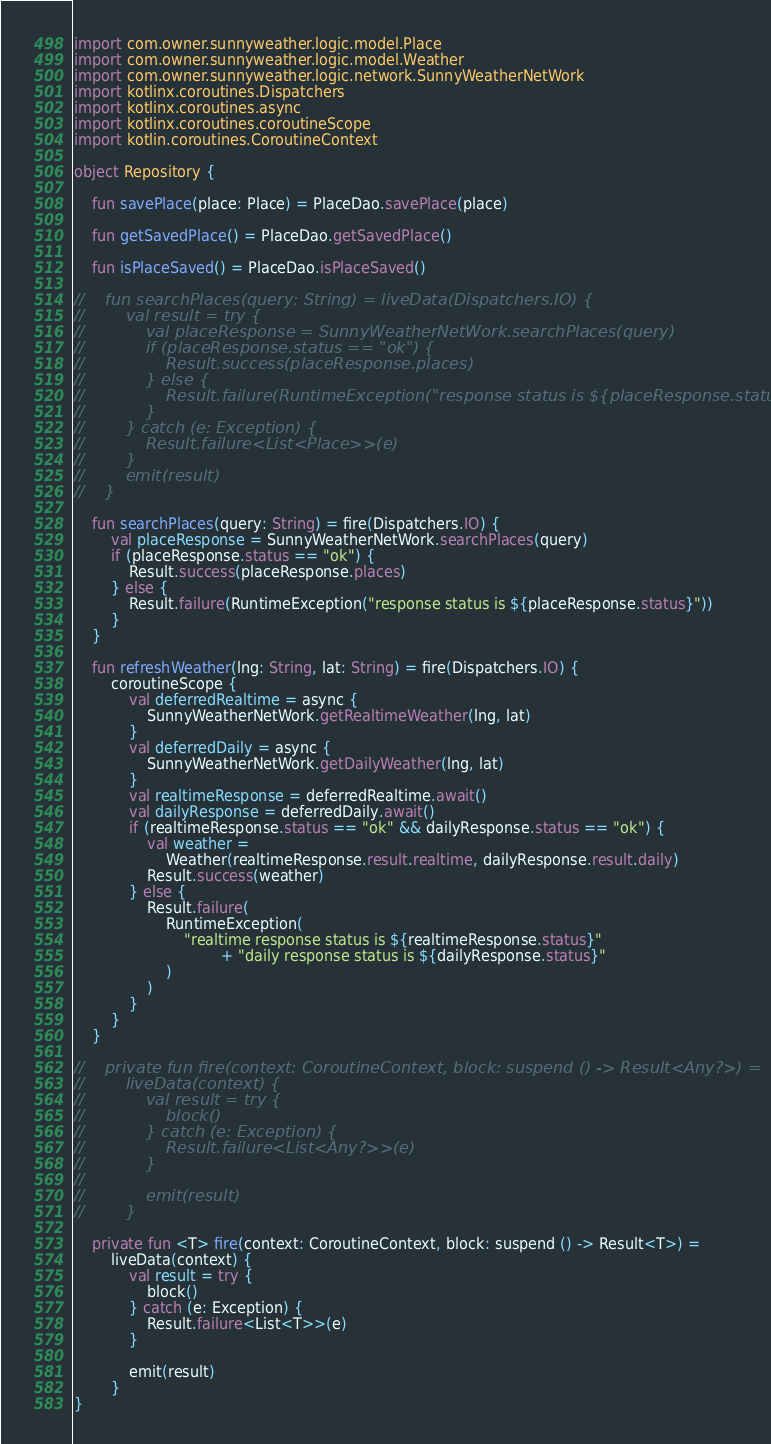<code> <loc_0><loc_0><loc_500><loc_500><_Kotlin_>import com.owner.sunnyweather.logic.model.Place
import com.owner.sunnyweather.logic.model.Weather
import com.owner.sunnyweather.logic.network.SunnyWeatherNetWork
import kotlinx.coroutines.Dispatchers
import kotlinx.coroutines.async
import kotlinx.coroutines.coroutineScope
import kotlin.coroutines.CoroutineContext

object Repository {

    fun savePlace(place: Place) = PlaceDao.savePlace(place)

    fun getSavedPlace() = PlaceDao.getSavedPlace()

    fun isPlaceSaved() = PlaceDao.isPlaceSaved()

//    fun searchPlaces(query: String) = liveData(Dispatchers.IO) {
//        val result = try {
//            val placeResponse = SunnyWeatherNetWork.searchPlaces(query)
//            if (placeResponse.status == "ok") {
//                Result.success(placeResponse.places)
//            } else {
//                Result.failure(RuntimeException("response status is ${placeResponse.status}"))
//            }
//        } catch (e: Exception) {
//            Result.failure<List<Place>>(e)
//        }
//        emit(result)
//    }

    fun searchPlaces(query: String) = fire(Dispatchers.IO) {
        val placeResponse = SunnyWeatherNetWork.searchPlaces(query)
        if (placeResponse.status == "ok") {
            Result.success(placeResponse.places)
        } else {
            Result.failure(RuntimeException("response status is ${placeResponse.status}"))
        }
    }

    fun refreshWeather(lng: String, lat: String) = fire(Dispatchers.IO) {
        coroutineScope {
            val deferredRealtime = async {
                SunnyWeatherNetWork.getRealtimeWeather(lng, lat)
            }
            val deferredDaily = async {
                SunnyWeatherNetWork.getDailyWeather(lng, lat)
            }
            val realtimeResponse = deferredRealtime.await()
            val dailyResponse = deferredDaily.await()
            if (realtimeResponse.status == "ok" && dailyResponse.status == "ok") {
                val weather =
                    Weather(realtimeResponse.result.realtime, dailyResponse.result.daily)
                Result.success(weather)
            } else {
                Result.failure(
                    RuntimeException(
                        "realtime response status is ${realtimeResponse.status}"
                                + "daily response status is ${dailyResponse.status}"
                    )
                )
            }
        }
    }

//    private fun fire(context: CoroutineContext, block: suspend () -> Result<Any?>) =
//        liveData(context) {
//            val result = try {
//                block()
//            } catch (e: Exception) {
//                Result.failure<List<Any?>>(e)
//            }
//
//            emit(result)
//        }

    private fun <T> fire(context: CoroutineContext, block: suspend () -> Result<T>) =
        liveData(context) {
            val result = try {
                block()
            } catch (e: Exception) {
                Result.failure<List<T>>(e)
            }

            emit(result)
        }
}</code> 